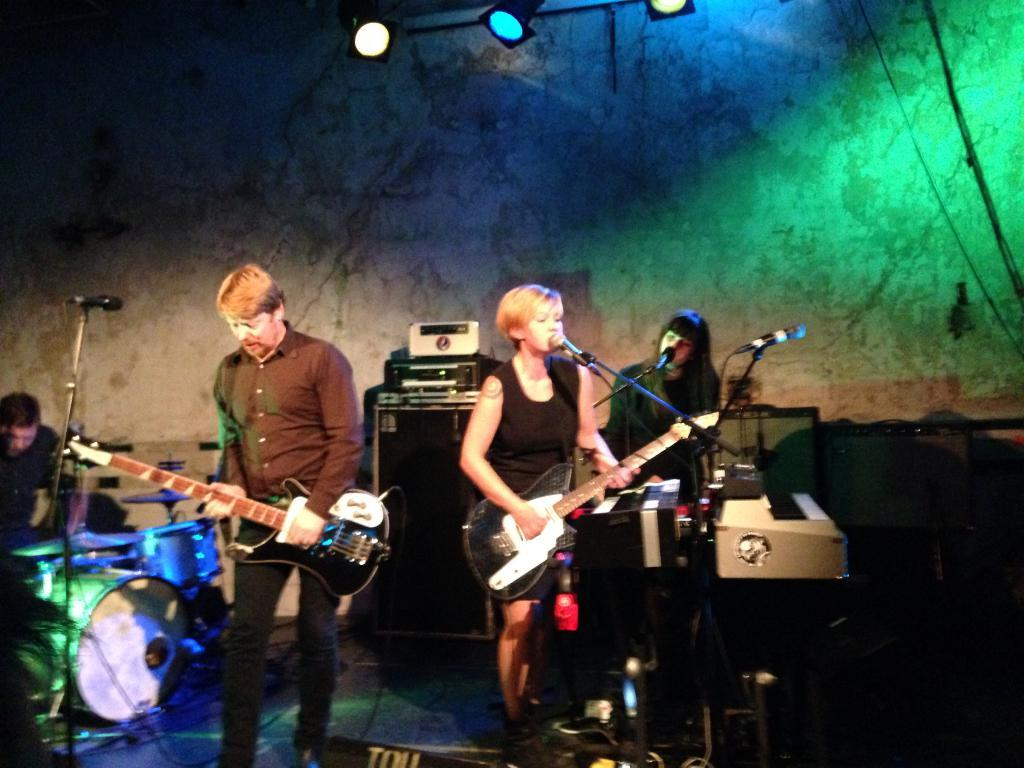What are the people in the image doing? The people in the image are playing musical instruments. Are any of the people singing while playing their instruments? Yes, two of the people are singing. What device might be used to amplify their voices? A microphone is present in the image. Can you tell me how many ranges are visible in the image? There are no ranges present in the image; it features people playing musical instruments and singing. Is there a bath visible in the image? No, there is no bath present in the image. 